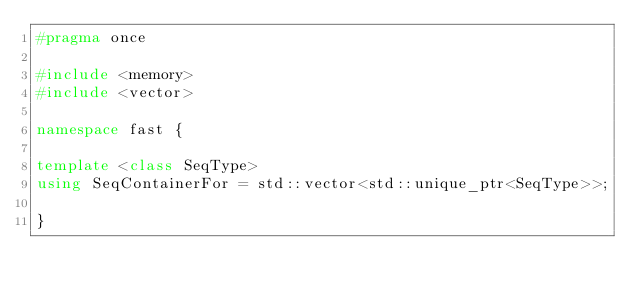Convert code to text. <code><loc_0><loc_0><loc_500><loc_500><_C++_>#pragma once

#include <memory>
#include <vector>

namespace fast {

template <class SeqType>
using SeqContainerFor = std::vector<std::unique_ptr<SeqType>>;

}
</code> 